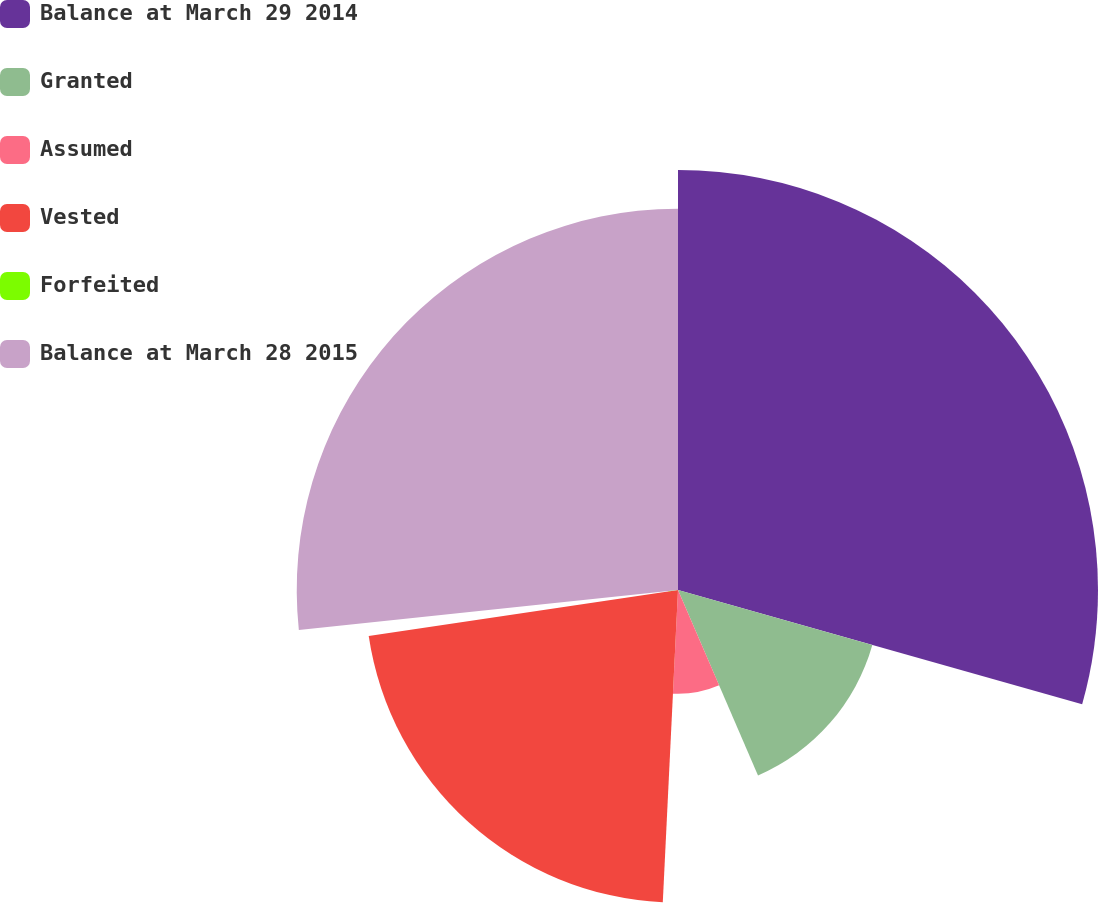Convert chart to OTSL. <chart><loc_0><loc_0><loc_500><loc_500><pie_chart><fcel>Balance at March 29 2014<fcel>Granted<fcel>Assumed<fcel>Vested<fcel>Forfeited<fcel>Balance at March 28 2015<nl><fcel>29.39%<fcel>14.13%<fcel>7.26%<fcel>21.88%<fcel>0.67%<fcel>26.68%<nl></chart> 